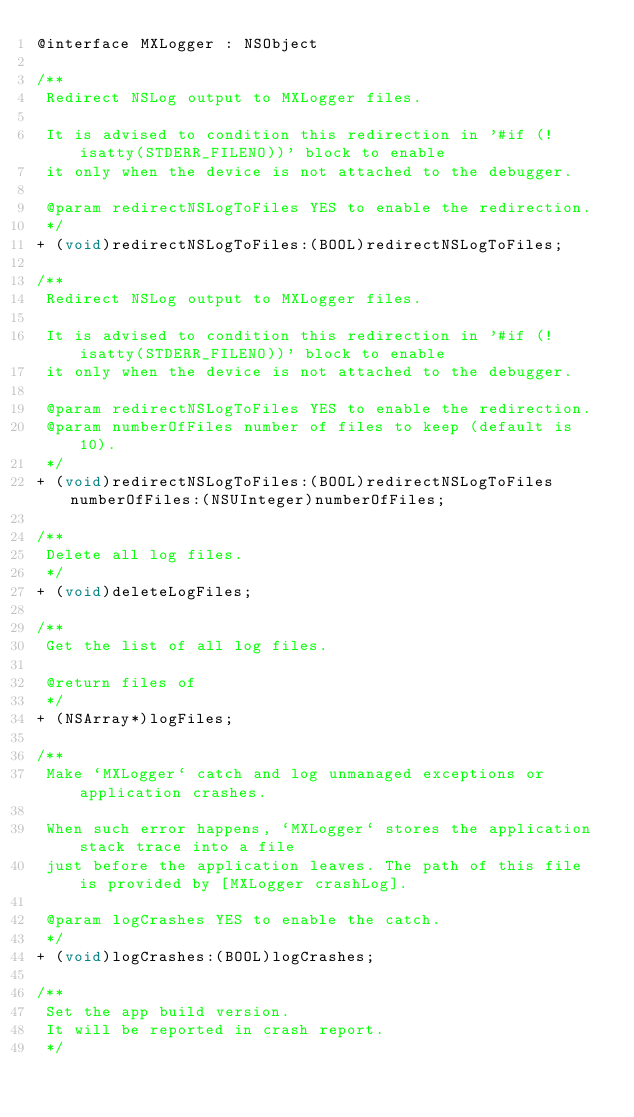<code> <loc_0><loc_0><loc_500><loc_500><_C_>@interface MXLogger : NSObject

/**
 Redirect NSLog output to MXLogger files.
 
 It is advised to condition this redirection in '#if (!isatty(STDERR_FILENO))' block to enable
 it only when the device is not attached to the debugger.

 @param redirectNSLogToFiles YES to enable the redirection.
 */
+ (void)redirectNSLogToFiles:(BOOL)redirectNSLogToFiles;

/**
 Redirect NSLog output to MXLogger files.
 
 It is advised to condition this redirection in '#if (!isatty(STDERR_FILENO))' block to enable
 it only when the device is not attached to the debugger.
 
 @param redirectNSLogToFiles YES to enable the redirection.
 @param numberOfFiles number of files to keep (default is 10).
 */
+ (void)redirectNSLogToFiles:(BOOL)redirectNSLogToFiles numberOfFiles:(NSUInteger)numberOfFiles;

/**
 Delete all log files.
 */
+ (void)deleteLogFiles;

/**
 Get the list of all log files.
 
 @return files of
 */
+ (NSArray*)logFiles;

/**
 Make `MXLogger` catch and log unmanaged exceptions or application crashes.

 When such error happens, `MXLogger` stores the application stack trace into a file
 just before the application leaves. The path of this file is provided by [MXLogger crashLog].
 
 @param logCrashes YES to enable the catch.
 */
+ (void)logCrashes:(BOOL)logCrashes;

/**
 Set the app build version.
 It will be reported in crash report.
 */</code> 